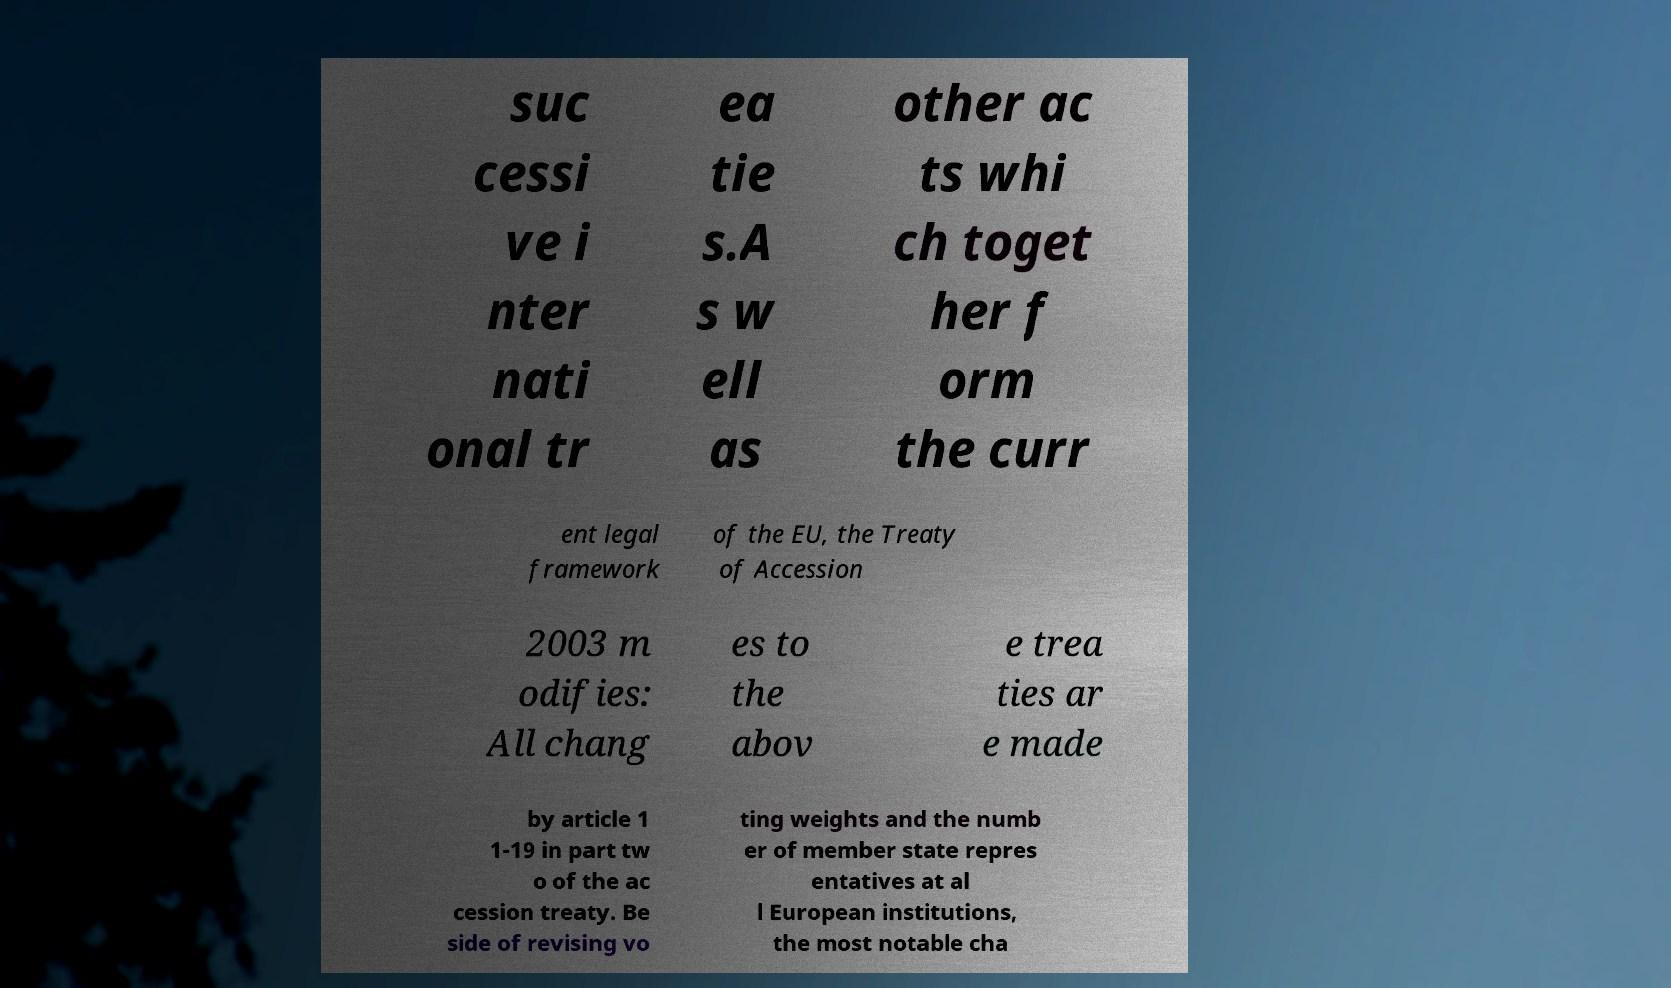For documentation purposes, I need the text within this image transcribed. Could you provide that? suc cessi ve i nter nati onal tr ea tie s.A s w ell as other ac ts whi ch toget her f orm the curr ent legal framework of the EU, the Treaty of Accession 2003 m odifies: All chang es to the abov e trea ties ar e made by article 1 1-19 in part tw o of the ac cession treaty. Be side of revising vo ting weights and the numb er of member state repres entatives at al l European institutions, the most notable cha 